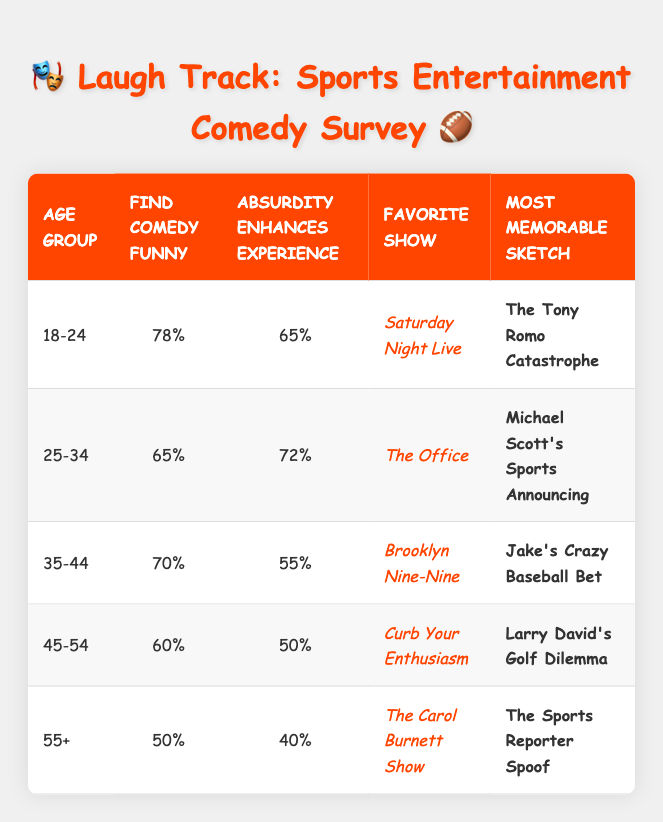What percentage of the 18-24 age group finds comedy funny? According to the table, the 18-24 age group has a percentage of 78% for finding comedy funny, which is directly stated in the "Find Comedy Funny" column under that age group.
Answer: 78% Which age group has the highest percentage who think absurdity enhances the experience? The highest percentage in the "Absurdity Enhances Experience" column is 72%, which is found in the 25-34 age group.
Answer: 25-34 Is it true that the 55+ age group has a higher percentage of people who find comedy funny than the 45-54 age group? The table shows that the 55+ age group has a percentage of 50% for finding comedy funny, while the 45-54 age group has a percentage of 60%. Therefore, it is false that the 55+ age group has a higher percentage.
Answer: No What is the average percentage of people finding comedy funny across all age groups? To calculate the average, sum the percentages: (78 + 65 + 70 + 60 + 50) = 323. Divide this by the number of age groups, which is 5: 323 / 5 = 64.6.
Answer: 64.6% Which age group has the most memorable sketch involving a sports reporter? The 55+ age group has the most memorable sketch listed as "The Sports Reporter Spoof," which is directly indicated in the last row of the table.
Answer: 55+ How many age groups have at least 65% of their audience finding comedy funny? Checking the percentages in the "Find Comedy Funny" column, the age groups 18-24 (78%), 25-34 (65%), and 35-44 (70%) meet the criteria. Thus, there are 3 age groups with at least 65%.
Answer: 3 What is the difference in percentage between the 25-34 and 35-44 age groups regarding absurdity enhancing the experience? The 25-34 age group has 72% and the 35-44 age group has 55%. The difference is 72% - 55% = 17%.
Answer: 17% Which age group has the favorite show "Curb Your Enthusiasm"? Looking at the "Favorite Show" column, the 45-54 age group is associated with "Curb Your Enthusiasm." This fact can be confirmed by referencing the corresponding row in the table.
Answer: 45-54 What is the most memorable sketch for the 35-44 age group? The table indicates that the most memorable sketch for the 35-44 age group is "Jake's Crazy Baseball Bet," as stated in the corresponding row.
Answer: Jake's Crazy Baseball Bet 